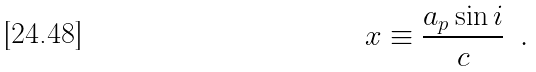<formula> <loc_0><loc_0><loc_500><loc_500>x \equiv \frac { a _ { p } \sin i } { c } \ \, .</formula> 